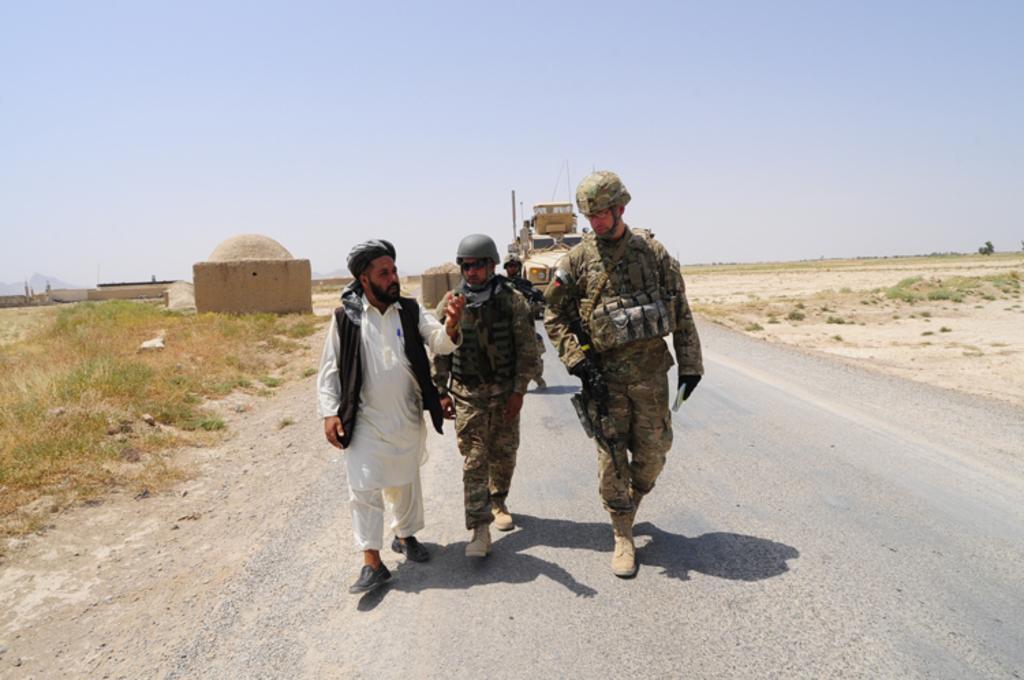Could you give a brief overview of what you see in this image? In this image we can see the people and vehicle on the road. And we can see a grass, house and sky in the background. 